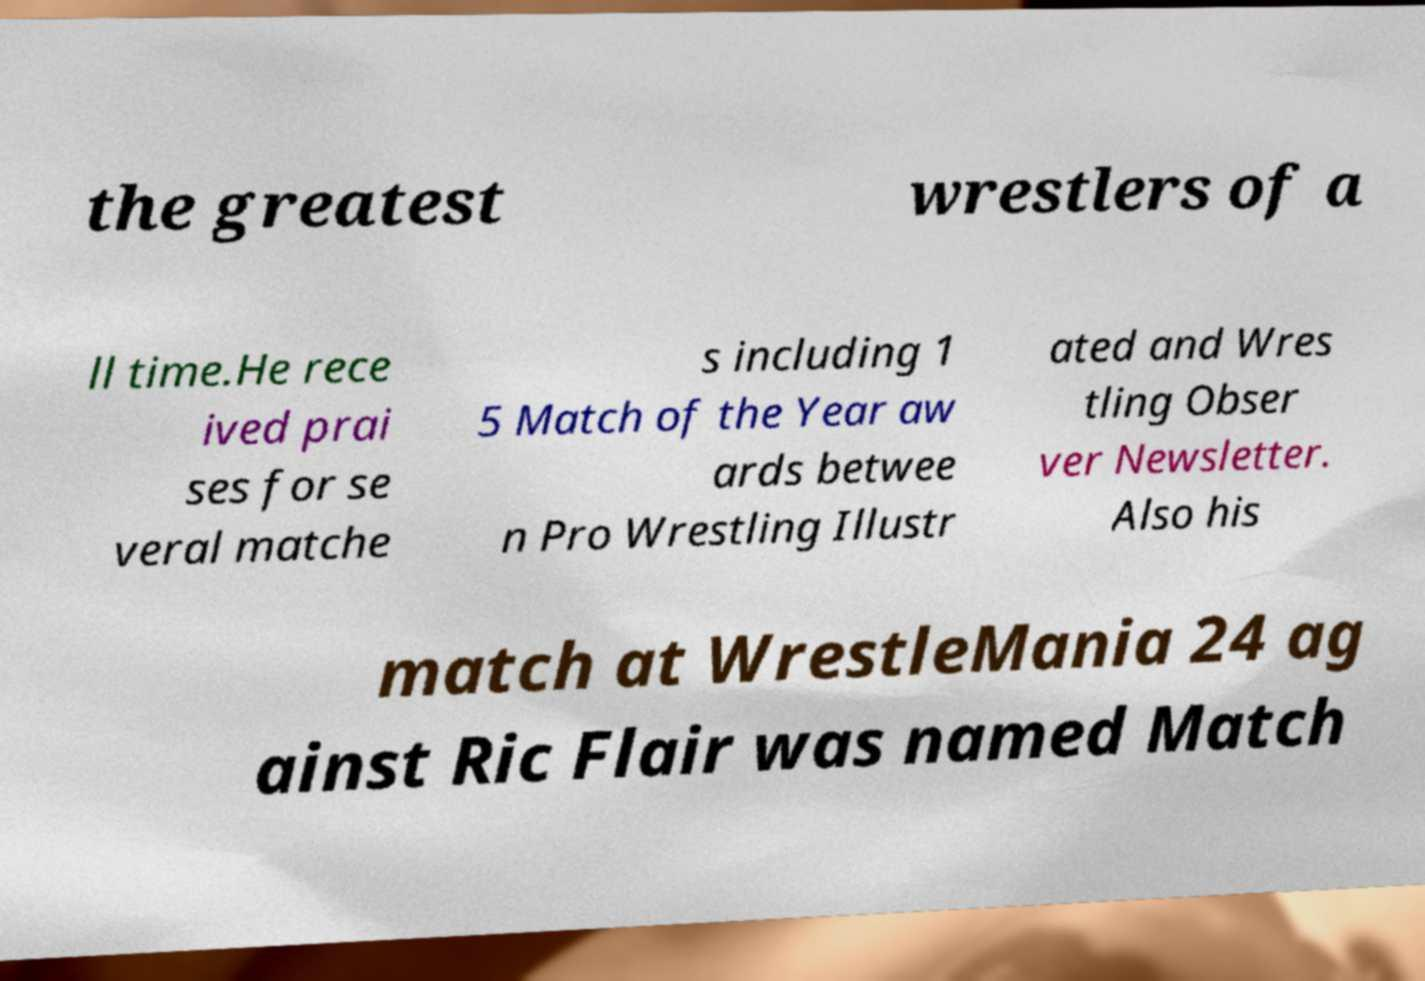Could you assist in decoding the text presented in this image and type it out clearly? the greatest wrestlers of a ll time.He rece ived prai ses for se veral matche s including 1 5 Match of the Year aw ards betwee n Pro Wrestling Illustr ated and Wres tling Obser ver Newsletter. Also his match at WrestleMania 24 ag ainst Ric Flair was named Match 